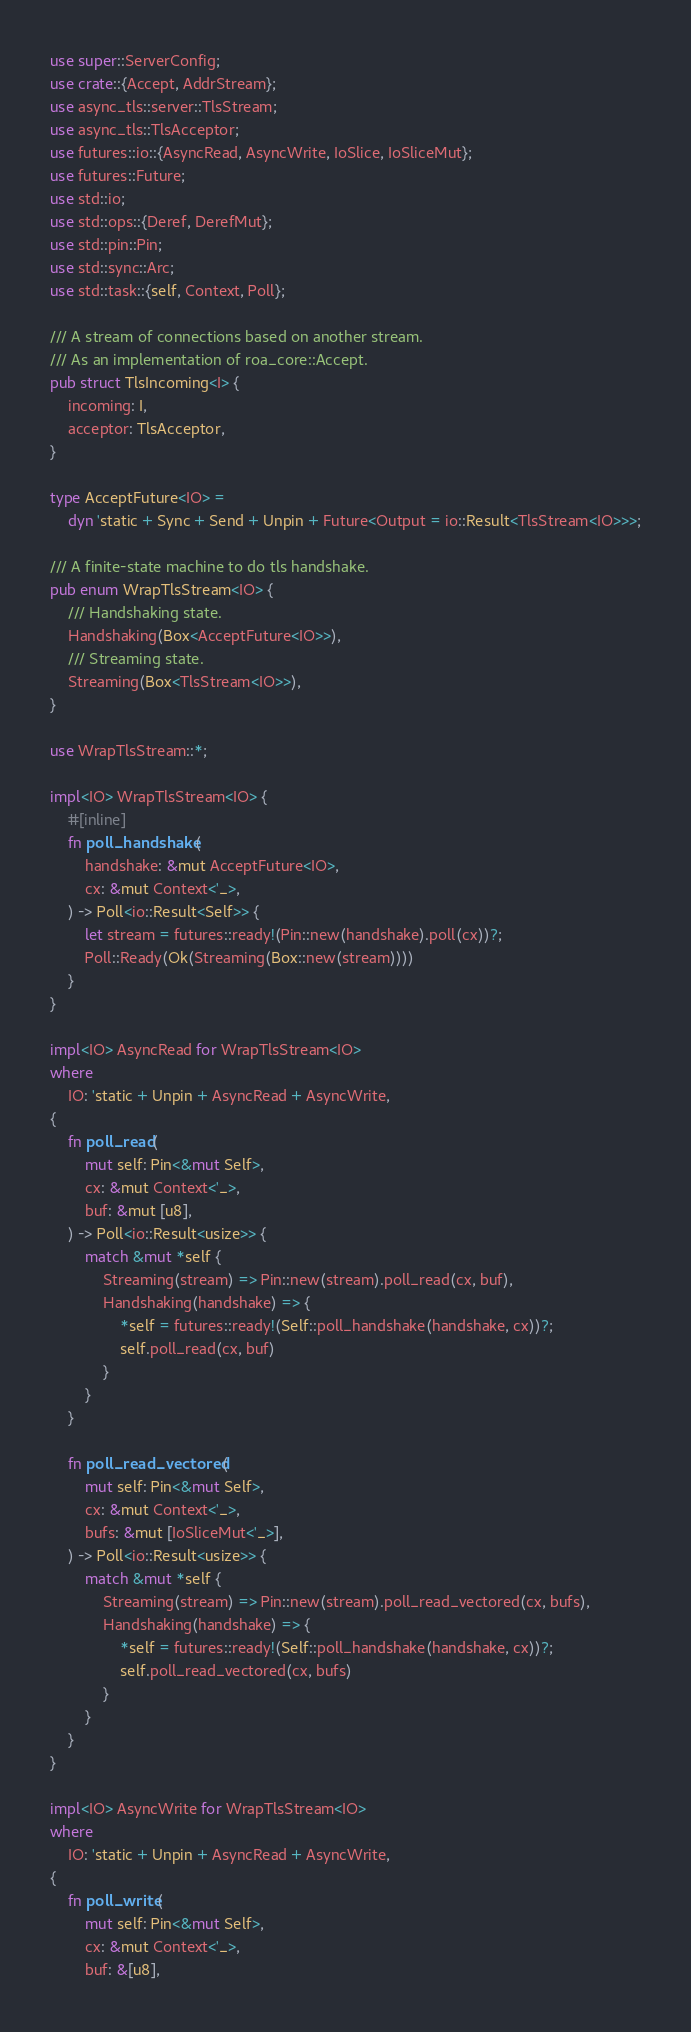Convert code to text. <code><loc_0><loc_0><loc_500><loc_500><_Rust_>use super::ServerConfig;
use crate::{Accept, AddrStream};
use async_tls::server::TlsStream;
use async_tls::TlsAcceptor;
use futures::io::{AsyncRead, AsyncWrite, IoSlice, IoSliceMut};
use futures::Future;
use std::io;
use std::ops::{Deref, DerefMut};
use std::pin::Pin;
use std::sync::Arc;
use std::task::{self, Context, Poll};

/// A stream of connections based on another stream.
/// As an implementation of roa_core::Accept.
pub struct TlsIncoming<I> {
    incoming: I,
    acceptor: TlsAcceptor,
}

type AcceptFuture<IO> =
    dyn 'static + Sync + Send + Unpin + Future<Output = io::Result<TlsStream<IO>>>;

/// A finite-state machine to do tls handshake.
pub enum WrapTlsStream<IO> {
    /// Handshaking state.
    Handshaking(Box<AcceptFuture<IO>>),
    /// Streaming state.
    Streaming(Box<TlsStream<IO>>),
}

use WrapTlsStream::*;

impl<IO> WrapTlsStream<IO> {
    #[inline]
    fn poll_handshake(
        handshake: &mut AcceptFuture<IO>,
        cx: &mut Context<'_>,
    ) -> Poll<io::Result<Self>> {
        let stream = futures::ready!(Pin::new(handshake).poll(cx))?;
        Poll::Ready(Ok(Streaming(Box::new(stream))))
    }
}

impl<IO> AsyncRead for WrapTlsStream<IO>
where
    IO: 'static + Unpin + AsyncRead + AsyncWrite,
{
    fn poll_read(
        mut self: Pin<&mut Self>,
        cx: &mut Context<'_>,
        buf: &mut [u8],
    ) -> Poll<io::Result<usize>> {
        match &mut *self {
            Streaming(stream) => Pin::new(stream).poll_read(cx, buf),
            Handshaking(handshake) => {
                *self = futures::ready!(Self::poll_handshake(handshake, cx))?;
                self.poll_read(cx, buf)
            }
        }
    }

    fn poll_read_vectored(
        mut self: Pin<&mut Self>,
        cx: &mut Context<'_>,
        bufs: &mut [IoSliceMut<'_>],
    ) -> Poll<io::Result<usize>> {
        match &mut *self {
            Streaming(stream) => Pin::new(stream).poll_read_vectored(cx, bufs),
            Handshaking(handshake) => {
                *self = futures::ready!(Self::poll_handshake(handshake, cx))?;
                self.poll_read_vectored(cx, bufs)
            }
        }
    }
}

impl<IO> AsyncWrite for WrapTlsStream<IO>
where
    IO: 'static + Unpin + AsyncRead + AsyncWrite,
{
    fn poll_write(
        mut self: Pin<&mut Self>,
        cx: &mut Context<'_>,
        buf: &[u8],</code> 